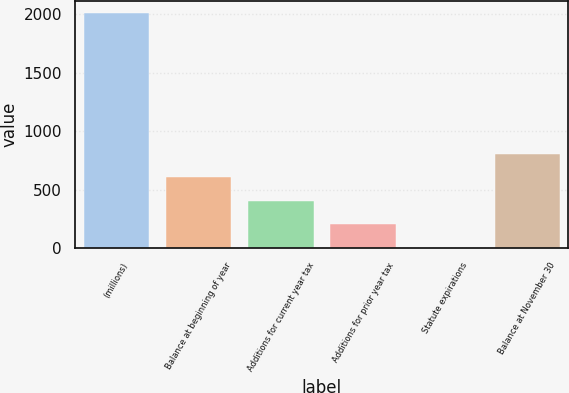Convert chart to OTSL. <chart><loc_0><loc_0><loc_500><loc_500><bar_chart><fcel>(millions)<fcel>Balance at beginning of year<fcel>Additions for current year tax<fcel>Additions for prior year tax<fcel>Statute expirations<fcel>Balance at November 30<nl><fcel>2012<fcel>604.44<fcel>403.36<fcel>202.28<fcel>1.2<fcel>805.52<nl></chart> 